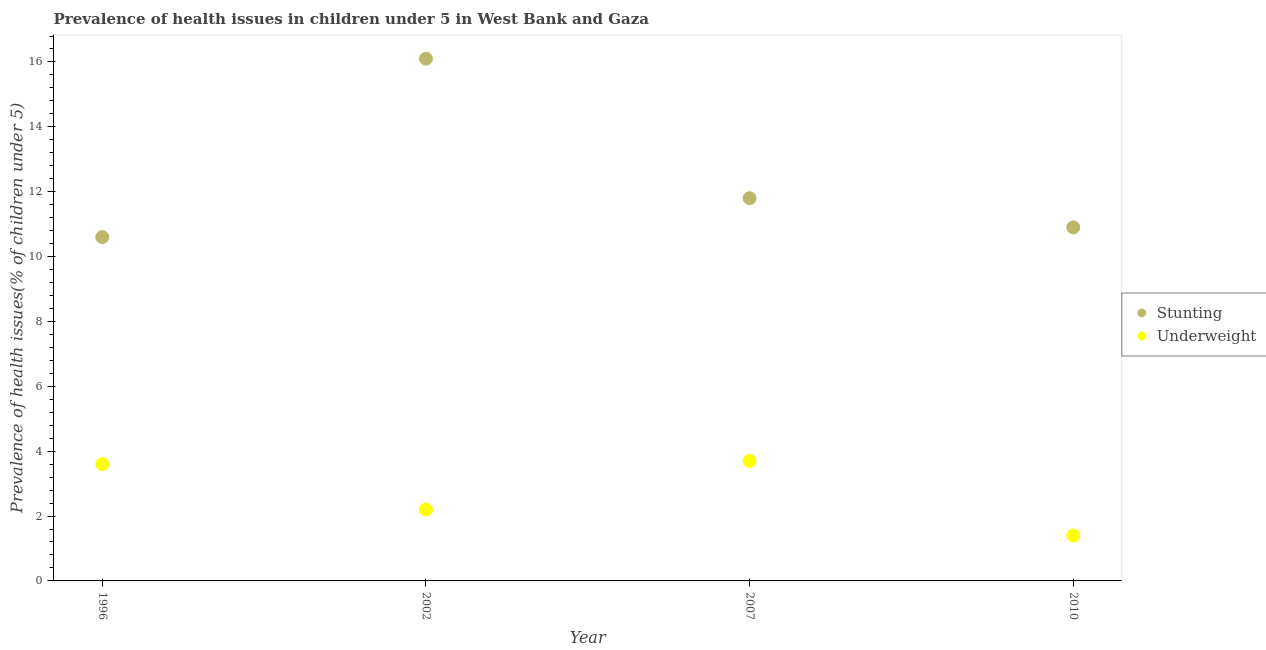Is the number of dotlines equal to the number of legend labels?
Provide a succinct answer. Yes. What is the percentage of underweight children in 2002?
Make the answer very short. 2.2. Across all years, what is the maximum percentage of underweight children?
Give a very brief answer. 3.7. Across all years, what is the minimum percentage of stunted children?
Your answer should be compact. 10.6. What is the total percentage of stunted children in the graph?
Give a very brief answer. 49.4. What is the difference between the percentage of underweight children in 1996 and that in 2007?
Keep it short and to the point. -0.1. What is the difference between the percentage of underweight children in 2002 and the percentage of stunted children in 1996?
Provide a short and direct response. -8.4. What is the average percentage of stunted children per year?
Keep it short and to the point. 12.35. In the year 2010, what is the difference between the percentage of stunted children and percentage of underweight children?
Give a very brief answer. 9.5. In how many years, is the percentage of stunted children greater than 2.4 %?
Your answer should be compact. 4. What is the ratio of the percentage of stunted children in 2002 to that in 2010?
Offer a terse response. 1.48. What is the difference between the highest and the second highest percentage of stunted children?
Ensure brevity in your answer.  4.3. What is the difference between the highest and the lowest percentage of underweight children?
Give a very brief answer. 2.3. In how many years, is the percentage of underweight children greater than the average percentage of underweight children taken over all years?
Offer a very short reply. 2. How many years are there in the graph?
Ensure brevity in your answer.  4. Are the values on the major ticks of Y-axis written in scientific E-notation?
Your response must be concise. No. Where does the legend appear in the graph?
Give a very brief answer. Center right. How many legend labels are there?
Your answer should be very brief. 2. What is the title of the graph?
Provide a short and direct response. Prevalence of health issues in children under 5 in West Bank and Gaza. What is the label or title of the X-axis?
Give a very brief answer. Year. What is the label or title of the Y-axis?
Your response must be concise. Prevalence of health issues(% of children under 5). What is the Prevalence of health issues(% of children under 5) in Stunting in 1996?
Your response must be concise. 10.6. What is the Prevalence of health issues(% of children under 5) of Underweight in 1996?
Offer a terse response. 3.6. What is the Prevalence of health issues(% of children under 5) of Stunting in 2002?
Give a very brief answer. 16.1. What is the Prevalence of health issues(% of children under 5) of Underweight in 2002?
Offer a very short reply. 2.2. What is the Prevalence of health issues(% of children under 5) of Stunting in 2007?
Offer a terse response. 11.8. What is the Prevalence of health issues(% of children under 5) in Underweight in 2007?
Keep it short and to the point. 3.7. What is the Prevalence of health issues(% of children under 5) in Stunting in 2010?
Make the answer very short. 10.9. What is the Prevalence of health issues(% of children under 5) of Underweight in 2010?
Offer a very short reply. 1.4. Across all years, what is the maximum Prevalence of health issues(% of children under 5) of Stunting?
Offer a terse response. 16.1. Across all years, what is the maximum Prevalence of health issues(% of children under 5) of Underweight?
Offer a terse response. 3.7. Across all years, what is the minimum Prevalence of health issues(% of children under 5) of Stunting?
Provide a short and direct response. 10.6. Across all years, what is the minimum Prevalence of health issues(% of children under 5) in Underweight?
Your answer should be compact. 1.4. What is the total Prevalence of health issues(% of children under 5) of Stunting in the graph?
Provide a succinct answer. 49.4. What is the difference between the Prevalence of health issues(% of children under 5) in Stunting in 2002 and that in 2010?
Make the answer very short. 5.2. What is the difference between the Prevalence of health issues(% of children under 5) in Underweight in 2002 and that in 2010?
Offer a very short reply. 0.8. What is the difference between the Prevalence of health issues(% of children under 5) in Stunting in 2007 and that in 2010?
Your answer should be compact. 0.9. What is the difference between the Prevalence of health issues(% of children under 5) of Stunting in 1996 and the Prevalence of health issues(% of children under 5) of Underweight in 2002?
Offer a very short reply. 8.4. What is the difference between the Prevalence of health issues(% of children under 5) in Stunting in 1996 and the Prevalence of health issues(% of children under 5) in Underweight in 2007?
Offer a terse response. 6.9. What is the difference between the Prevalence of health issues(% of children under 5) in Stunting in 2002 and the Prevalence of health issues(% of children under 5) in Underweight in 2007?
Provide a succinct answer. 12.4. What is the difference between the Prevalence of health issues(% of children under 5) in Stunting in 2002 and the Prevalence of health issues(% of children under 5) in Underweight in 2010?
Your answer should be very brief. 14.7. What is the average Prevalence of health issues(% of children under 5) of Stunting per year?
Offer a very short reply. 12.35. What is the average Prevalence of health issues(% of children under 5) in Underweight per year?
Your answer should be very brief. 2.73. In the year 1996, what is the difference between the Prevalence of health issues(% of children under 5) in Stunting and Prevalence of health issues(% of children under 5) in Underweight?
Provide a short and direct response. 7. In the year 2002, what is the difference between the Prevalence of health issues(% of children under 5) in Stunting and Prevalence of health issues(% of children under 5) in Underweight?
Keep it short and to the point. 13.9. In the year 2010, what is the difference between the Prevalence of health issues(% of children under 5) in Stunting and Prevalence of health issues(% of children under 5) in Underweight?
Give a very brief answer. 9.5. What is the ratio of the Prevalence of health issues(% of children under 5) in Stunting in 1996 to that in 2002?
Offer a very short reply. 0.66. What is the ratio of the Prevalence of health issues(% of children under 5) in Underweight in 1996 to that in 2002?
Your answer should be compact. 1.64. What is the ratio of the Prevalence of health issues(% of children under 5) of Stunting in 1996 to that in 2007?
Your answer should be compact. 0.9. What is the ratio of the Prevalence of health issues(% of children under 5) of Stunting in 1996 to that in 2010?
Your response must be concise. 0.97. What is the ratio of the Prevalence of health issues(% of children under 5) in Underweight in 1996 to that in 2010?
Ensure brevity in your answer.  2.57. What is the ratio of the Prevalence of health issues(% of children under 5) in Stunting in 2002 to that in 2007?
Make the answer very short. 1.36. What is the ratio of the Prevalence of health issues(% of children under 5) in Underweight in 2002 to that in 2007?
Your answer should be compact. 0.59. What is the ratio of the Prevalence of health issues(% of children under 5) of Stunting in 2002 to that in 2010?
Ensure brevity in your answer.  1.48. What is the ratio of the Prevalence of health issues(% of children under 5) of Underweight in 2002 to that in 2010?
Ensure brevity in your answer.  1.57. What is the ratio of the Prevalence of health issues(% of children under 5) in Stunting in 2007 to that in 2010?
Your response must be concise. 1.08. What is the ratio of the Prevalence of health issues(% of children under 5) in Underweight in 2007 to that in 2010?
Ensure brevity in your answer.  2.64. What is the difference between the highest and the second highest Prevalence of health issues(% of children under 5) in Stunting?
Ensure brevity in your answer.  4.3. What is the difference between the highest and the lowest Prevalence of health issues(% of children under 5) in Stunting?
Your answer should be very brief. 5.5. What is the difference between the highest and the lowest Prevalence of health issues(% of children under 5) in Underweight?
Your response must be concise. 2.3. 